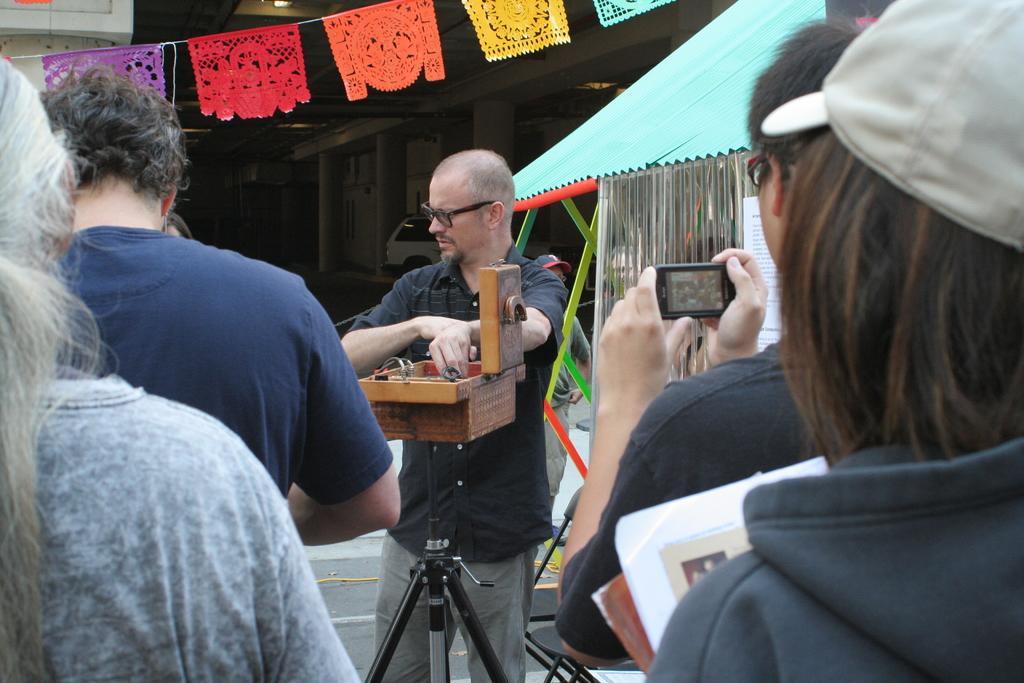How would you summarize this image in a sentence or two? In this picture we can see a group of people and one person is holding a mobile, here we can see a tent and some objects and in the background we can see a vehicle, building. 